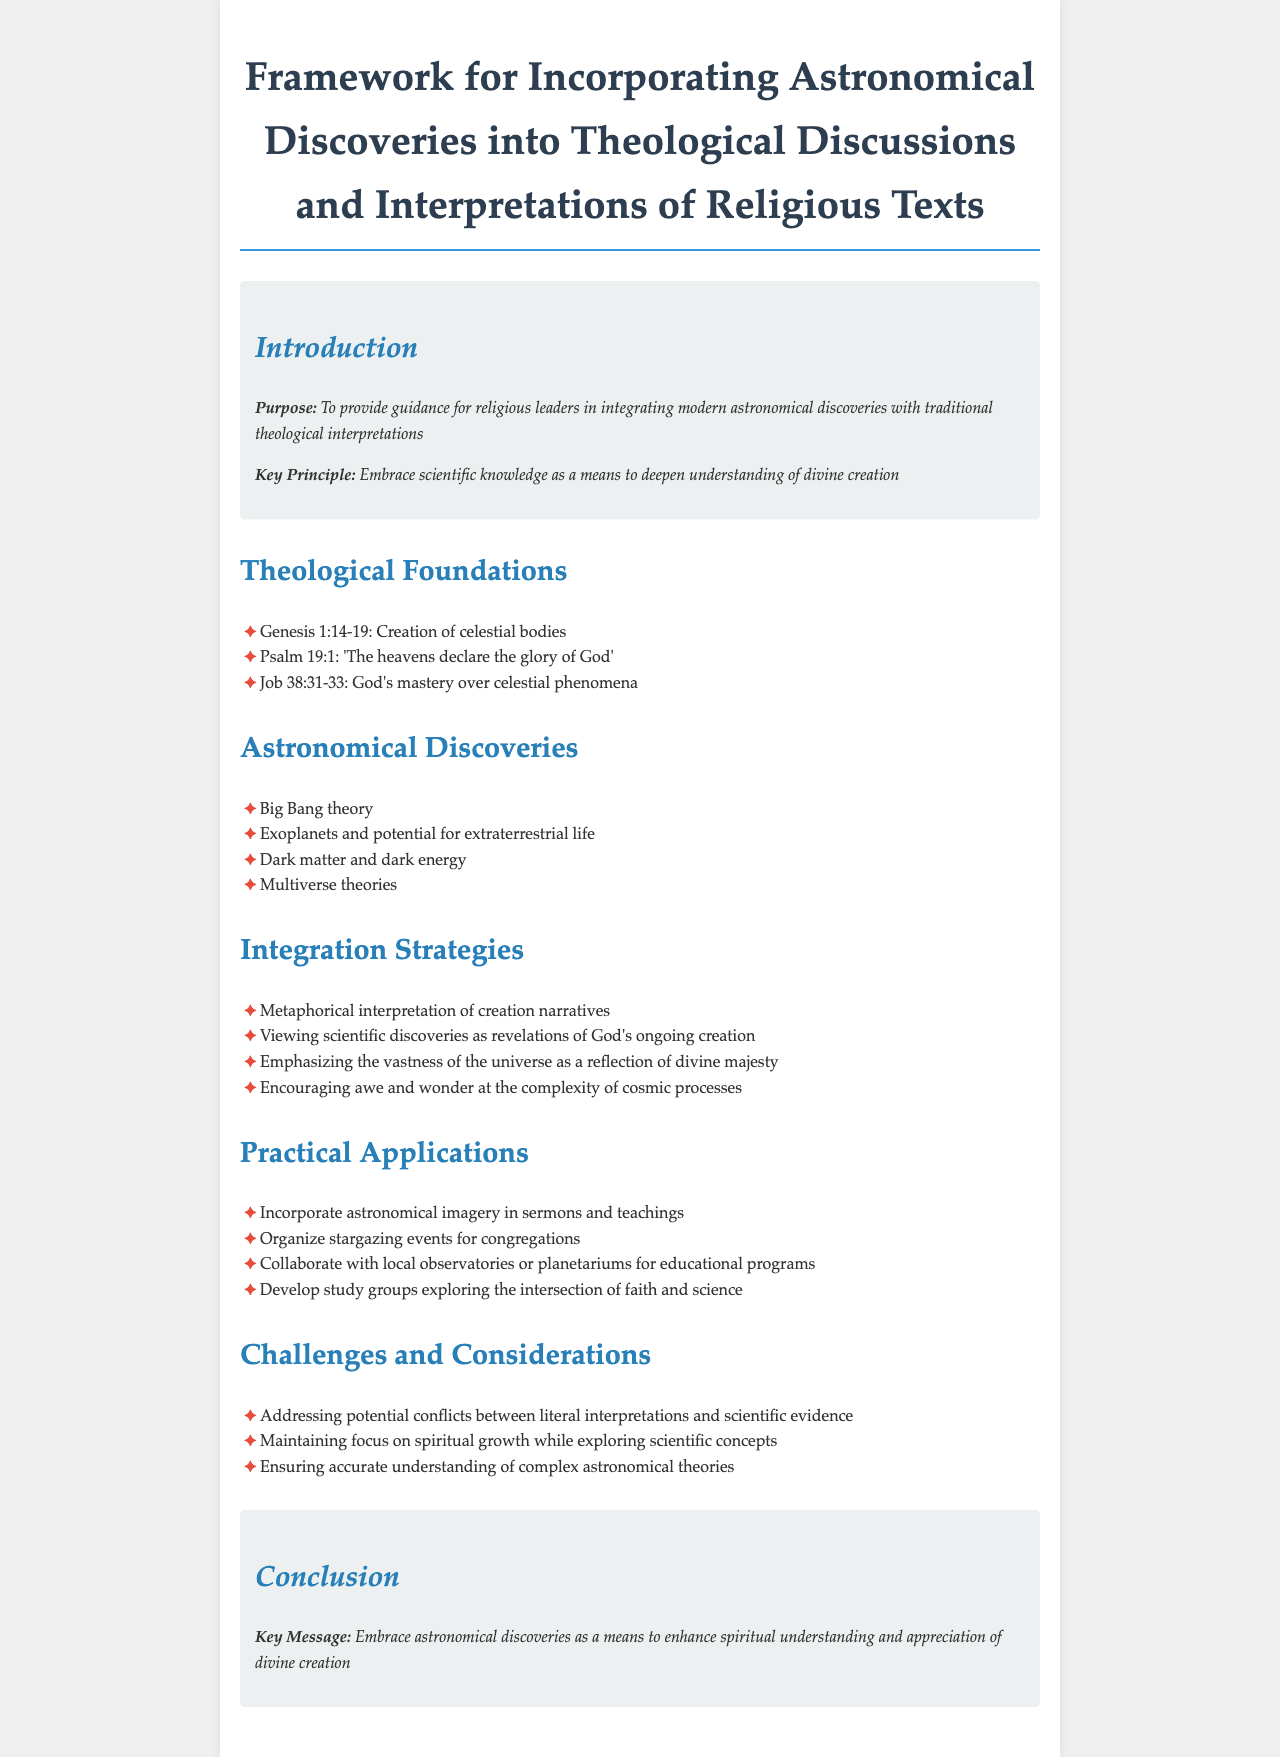What is the primary purpose of the document? The document's primary purpose is to provide guidance for religious leaders in integrating modern astronomical discoveries with traditional theological interpretations.
Answer: To provide guidance for religious leaders in integrating modern astronomical discoveries with traditional theological interpretations Which Psalm verse is mentioned in the theological foundations? The theological foundations section includes Psalm 19:1, which mentions that 'The heavens declare the glory of God'.
Answer: Psalm 19:1 What is listed as one of the astronomical discoveries? The document lists several discoveries, including the Big Bang theory as one of them.
Answer: Big Bang theory What is one of the integration strategies suggested in the document? The document suggests viewing scientific discoveries as revelations of God's ongoing creation as one of the integration strategies.
Answer: Viewing scientific discoveries as revelations of God's ongoing creation What key message is reiterated in the conclusion? The conclusion states that the key message is to embrace astronomical discoveries as a means to enhance spiritual understanding and appreciation of divine creation.
Answer: Embrace astronomical discoveries as a means to enhance spiritual understanding and appreciation of divine creation What challenge does the document mention regarding interpretations? The document mentions addressing potential conflicts between literal interpretations and scientific evidence as a challenge.
Answer: Addressing potential conflicts between literal interpretations and scientific evidence Which section talks about practical applications? The section titled "Practical Applications" discusses various activities that can be integrated into religious practice.
Answer: Practical Applications 